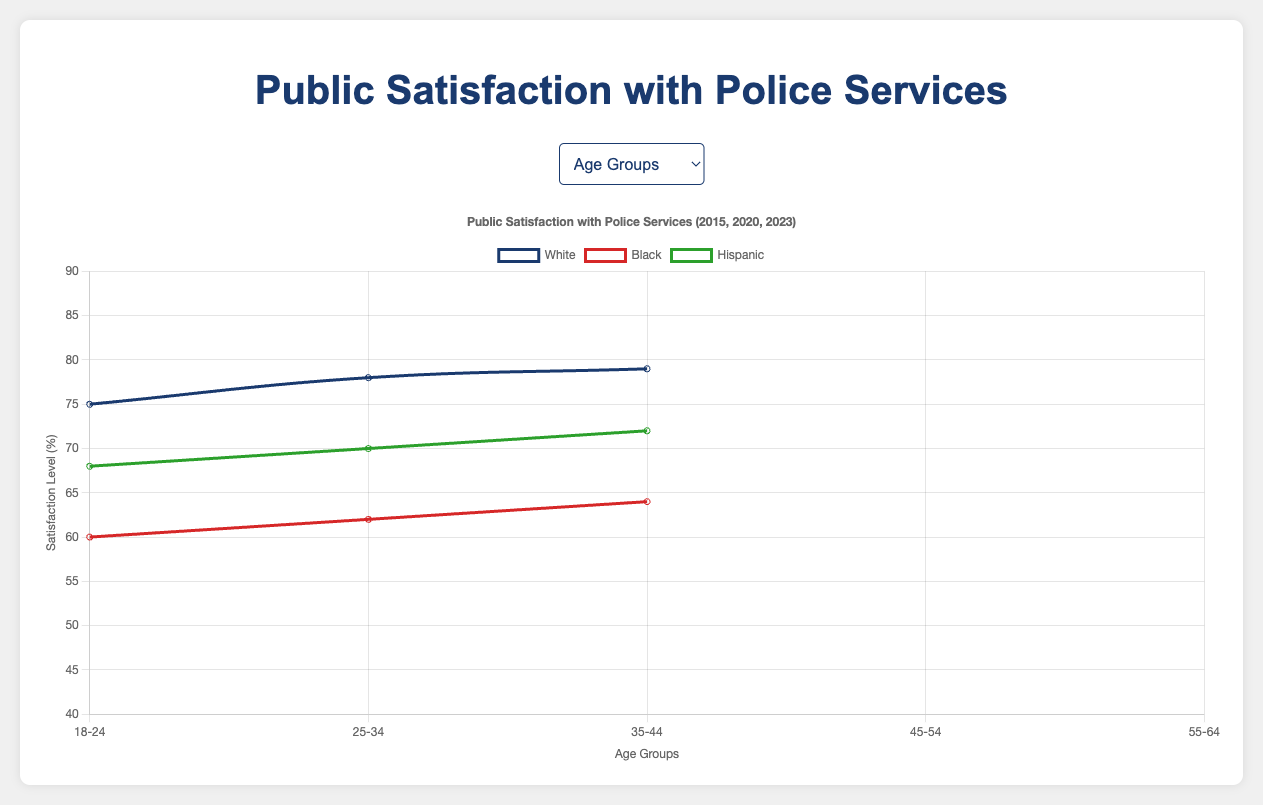Which age group of white respondents showed the highest satisfaction level in 2023? In the 2023 dataset for white respondents, the highest satisfaction level is found in the age_35_44 group with a score of 83.
Answer: age_35_44 Between low-income and high-income black respondents in 2020, which group had a higher satisfaction level? In the 2020 dataset for black respondents, the high-income group had a satisfaction level of 68, while the low-income group had 52.
Answer: High income How did the satisfaction level of middle-income Hispanic respondents change from 2015 to 2023? The satisfaction level for middle-income Hispanic respondents increased from 70 in 2015 to 75 in 2023.
Answer: increased by 5 Which demographic had the lowest satisfaction level in 2015? In the 2015 dataset, black low-income respondents had the lowest satisfaction level, with a score of 50.
Answer: black low-income In 2023, compare the satisfaction levels between black and Hispanic respondents aged 25-34. Who had higher satisfaction? In 2023, black respondents aged 25-34 had a satisfaction level of 64, while Hispanic respondents in the same age group had 72.
Answer: Hispanic respondents Calculate the average satisfaction level of white respondents aged 18-24 across all years. The satisfaction levels for white respondents aged 18-24 are 70 (2015), 73 (2020), and 75 (2023). Average is (70 + 73 + 75) / 3 = 72.67.
Answer: 72.67 What was the trend in the satisfaction levels of low-income white respondents from 2015 to 2023? The satisfaction levels of low-income white respondents increased from 60 in 2015, to 63 in 2020, and then to 65 in 2023, indicating an upward trend.
Answer: upward trend Which group had a greater increase in satisfaction from 2020 to 2023: middle-income black or middle-income Hispanic respondents? Middle-income black respondents' satisfaction increased from 65 in 2020 to 68 in 2023, a change of 3. Middle-income Hispanic respondents' satisfaction increased from 73 in 2020 to 75 in 2023, a change of 2.
Answer: middle-income black respondents For which race did all age groups show an increase in satisfaction from 2015 to 2023? White respondents exhibited increases in satisfaction across all age groups from 2015 to 2023.
Answer: White 